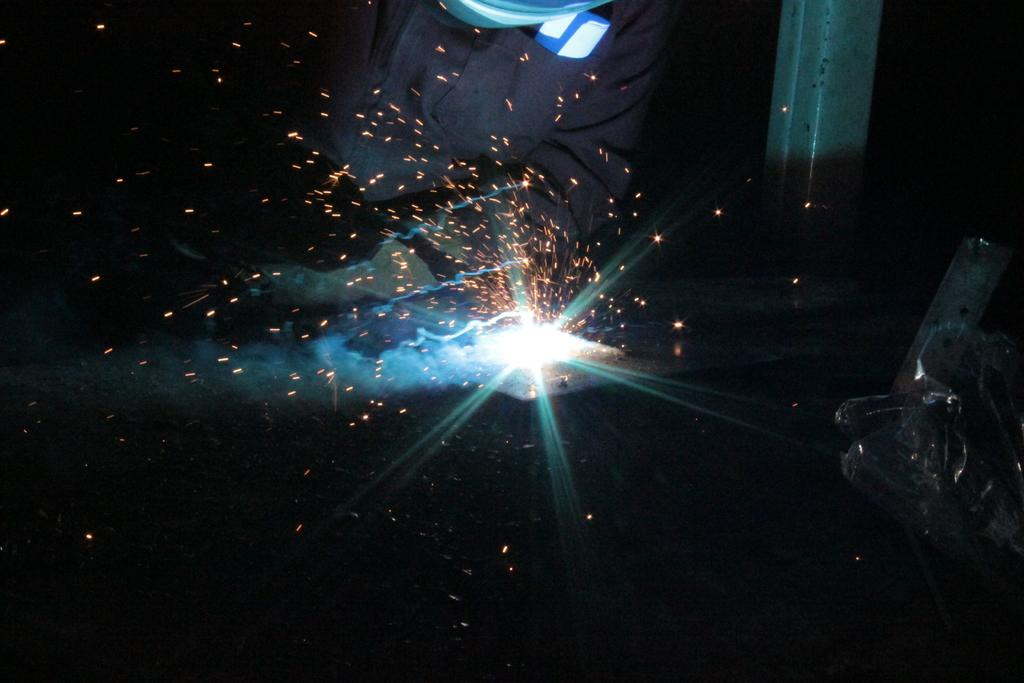What is happening in the image involving the person? The person is doing firework in the image. Can you describe the pole on the right side of the image? There is a pole on the right side of the image. What else can be seen in the image besides the person and the pole? There is an object in the image. What type of interest can be seen in the image? There is no reference to any interest in the image; it features a person doing firework and a pole. Is there any polish visible on the person or the pole in the image? There is no mention of polish in the image, and it is not visible in the provided facts. 